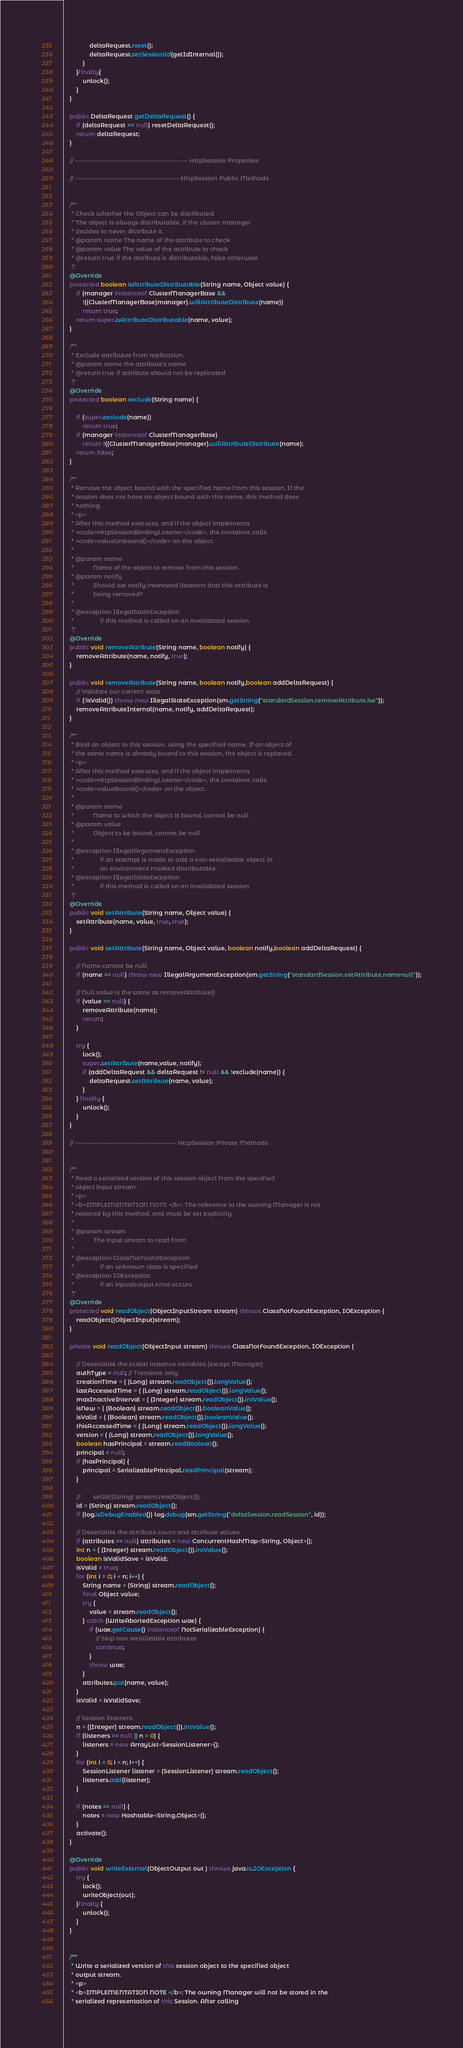Convert code to text. <code><loc_0><loc_0><loc_500><loc_500><_Java_>                deltaRequest.reset();
                deltaRequest.setSessionId(getIdInternal());
            }
        }finally{
            unlock();
        }
    }

    public DeltaRequest getDeltaRequest() {
        if (deltaRequest == null) resetDeltaRequest();
        return deltaRequest;
    }

    // ------------------------------------------------- HttpSession Properties

    // ----------------------------------------------HttpSession Public Methods


    /**
     * Check whether the Object can be distributed.
     * The object is always distributable, if the cluster manager
     * decides to never distribute it.
     * @param name The name of the attribute to check
     * @param value The value of the attribute to check
     * @return true if the attribute is distributable, false otherwise
     */
    @Override
    protected boolean isAttributeDistributable(String name, Object value) {
        if (manager instanceof ClusterManagerBase &&
            !((ClusterManagerBase)manager).willAttributeDistribute(name))
            return true;
        return super.isAttributeDistributable(name, value);
    }

    /**
     * Exclude attributes from replication.
     * @param name the attribute's name
     * @return true if attribute should not be replicated
     */
    @Override
    protected boolean exclude(String name) {

        if (super.exclude(name))
            return true;
        if (manager instanceof ClusterManagerBase)
            return !((ClusterManagerBase)manager).willAttributeDistribute(name);
        return false;
    }

    /**
     * Remove the object bound with the specified name from this session. If the
     * session does not have an object bound with this name, this method does
     * nothing.
     * <p>
     * After this method executes, and if the object implements
     * <code>HttpSessionBindingListener</code>, the container calls
     * <code>valueUnbound()</code> on the object.
     *
     * @param name
     *            Name of the object to remove from this session.
     * @param notify
     *            Should we notify interested listeners that this attribute is
     *            being removed?
     *
     * @exception IllegalStateException
     *                if this method is called on an invalidated session
     */
    @Override
    public void removeAttribute(String name, boolean notify) {
        removeAttribute(name, notify, true);
    }

    public void removeAttribute(String name, boolean notify,boolean addDeltaRequest) {
        // Validate our current state
        if (!isValid()) throw new IllegalStateException(sm.getString("standardSession.removeAttribute.ise"));
        removeAttributeInternal(name, notify, addDeltaRequest);
    }

    /**
     * Bind an object to this session, using the specified name. If an object of
     * the same name is already bound to this session, the object is replaced.
     * <p>
     * After this method executes, and if the object implements
     * <code>HttpSessionBindingListener</code>, the container calls
     * <code>valueBound()</code> on the object.
     *
     * @param name
     *            Name to which the object is bound, cannot be null
     * @param value
     *            Object to be bound, cannot be null
     *
     * @exception IllegalArgumentException
     *                if an attempt is made to add a non-serializable object in
     *                an environment marked distributable.
     * @exception IllegalStateException
     *                if this method is called on an invalidated session
     */
    @Override
    public void setAttribute(String name, Object value) {
        setAttribute(name, value, true, true);
    }

    public void setAttribute(String name, Object value, boolean notify,boolean addDeltaRequest) {

        // Name cannot be null
        if (name == null) throw new IllegalArgumentException(sm.getString("standardSession.setAttribute.namenull"));

        // Null value is the same as removeAttribute()
        if (value == null) {
            removeAttribute(name);
            return;
        }

        try {
            lock();
            super.setAttribute(name,value, notify);
            if (addDeltaRequest && deltaRequest != null && !exclude(name)) {
                deltaRequest.setAttribute(name, value);
            }
        } finally {
            unlock();
        }
    }

    // -------------------------------------------- HttpSession Private Methods


    /**
     * Read a serialized version of this session object from the specified
     * object input stream.
     * <p>
     * <b>IMPLEMENTATION NOTE </b>: The reference to the owning Manager is not
     * restored by this method, and must be set explicitly.
     *
     * @param stream
     *            The input stream to read from
     *
     * @exception ClassNotFoundException
     *                if an unknown class is specified
     * @exception IOException
     *                if an input/output error occurs
     */
    @Override
    protected void readObject(ObjectInputStream stream) throws ClassNotFoundException, IOException {
        readObject((ObjectInput)stream);
    }

    private void readObject(ObjectInput stream) throws ClassNotFoundException, IOException {

        // Deserialize the scalar instance variables (except Manager)
        authType = null; // Transient only
        creationTime = ( (Long) stream.readObject()).longValue();
        lastAccessedTime = ( (Long) stream.readObject()).longValue();
        maxInactiveInterval = ( (Integer) stream.readObject()).intValue();
        isNew = ( (Boolean) stream.readObject()).booleanValue();
        isValid = ( (Boolean) stream.readObject()).booleanValue();
        thisAccessedTime = ( (Long) stream.readObject()).longValue();
        version = ( (Long) stream.readObject()).longValue();
        boolean hasPrincipal = stream.readBoolean();
        principal = null;
        if (hasPrincipal) {
            principal = SerializablePrincipal.readPrincipal(stream);
        }

        //        setId((String) stream.readObject());
        id = (String) stream.readObject();
        if (log.isDebugEnabled()) log.debug(sm.getString("deltaSession.readSession", id));

        // Deserialize the attribute count and attribute values
        if (attributes == null) attributes = new ConcurrentHashMap<String, Object>();
        int n = ( (Integer) stream.readObject()).intValue();
        boolean isValidSave = isValid;
        isValid = true;
        for (int i = 0; i < n; i++) {
            String name = (String) stream.readObject();
            final Object value;
            try {
                value = stream.readObject();
            } catch (WriteAbortedException wae) {
                if (wae.getCause() instanceof NotSerializableException) {
                    // Skip non serializable attributes
                    continue;
                }
                throw wae;
            }
            attributes.put(name, value);
        }
        isValid = isValidSave;

        // Session listeners
        n = ((Integer) stream.readObject()).intValue();
        if (listeners == null || n > 0) {
            listeners = new ArrayList<SessionListener>();
        }
        for (int i = 0; i < n; i++) {
            SessionListener listener = (SessionListener) stream.readObject();
            listeners.add(listener);
        }

        if (notes == null) {
            notes = new Hashtable<String,Object>();
        }
        activate();
    }

    @Override
    public void writeExternal(ObjectOutput out ) throws java.io.IOException {
        try {
            lock();
            writeObject(out);
        }finally {
            unlock();
        }
    }


    /**
     * Write a serialized version of this session object to the specified object
     * output stream.
     * <p>
     * <b>IMPLEMENTATION NOTE </b>: The owning Manager will not be stored in the
     * serialized representation of this Session. After calling</code> 